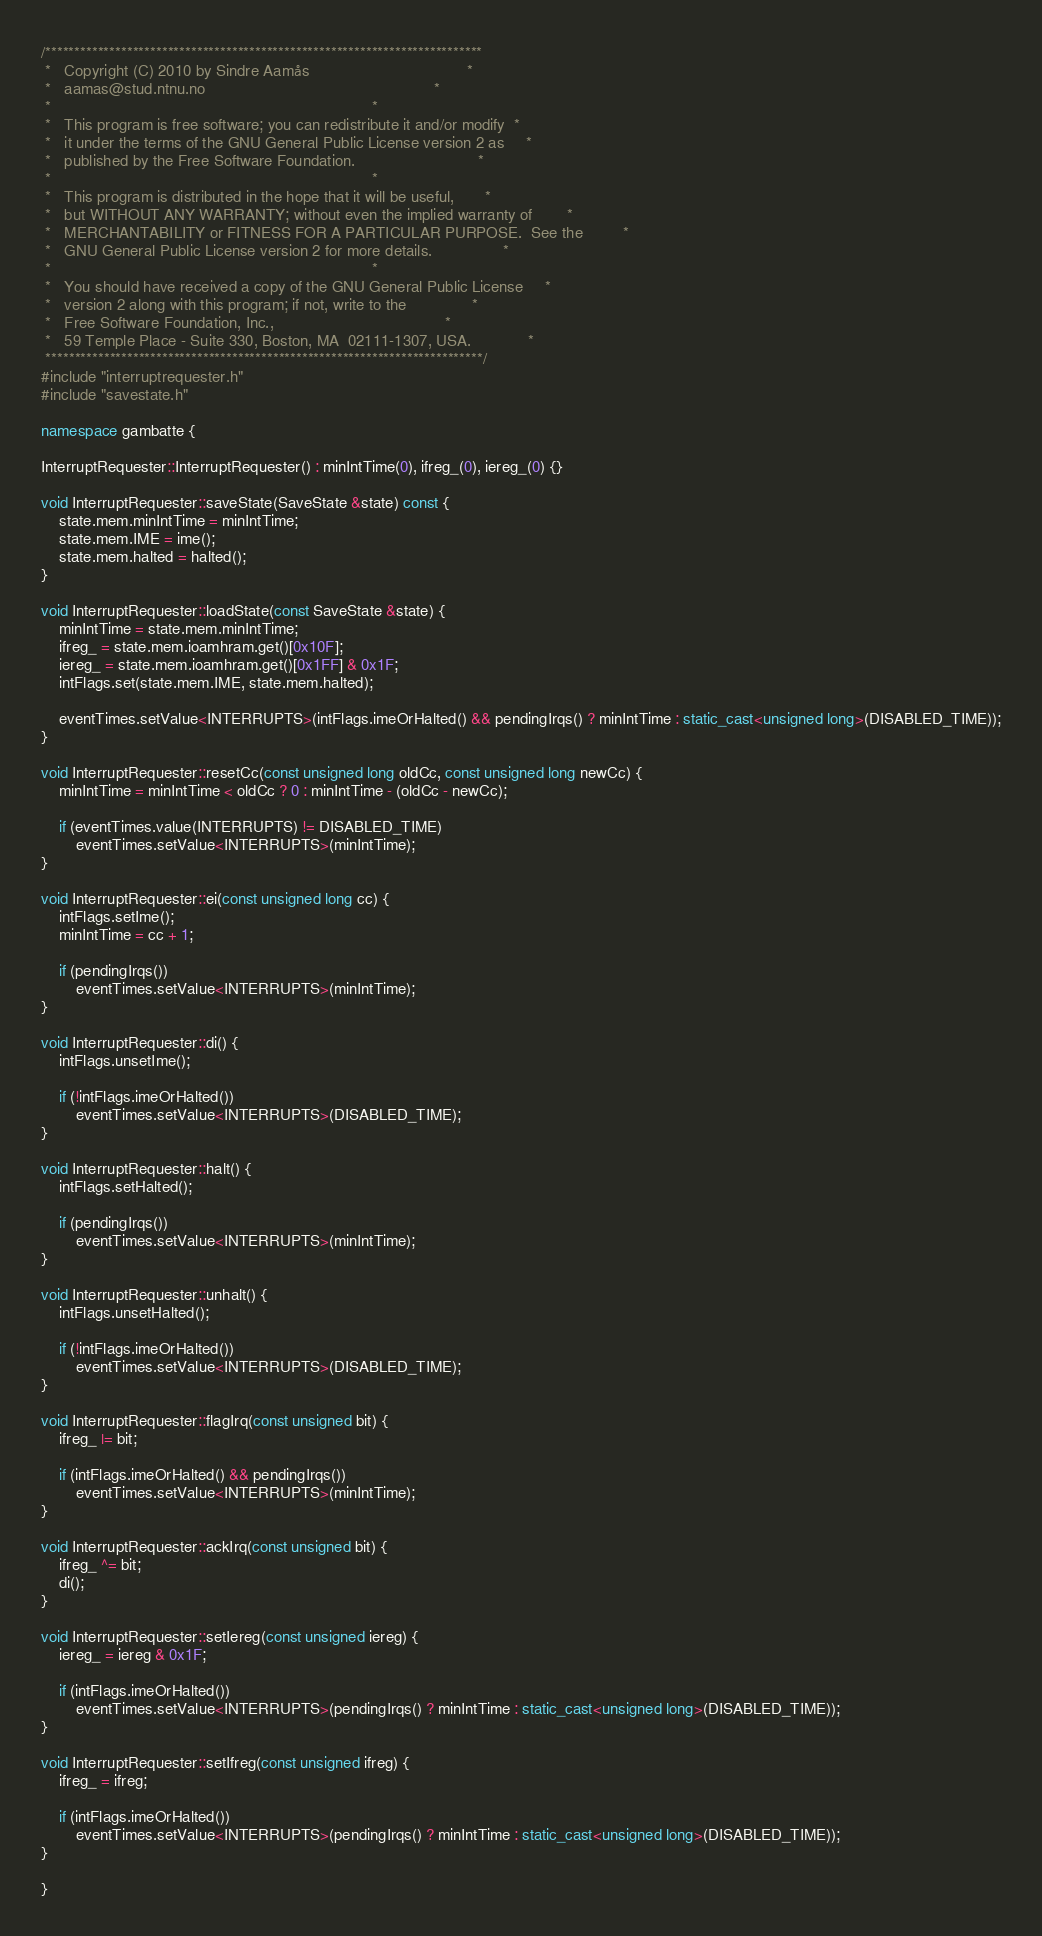Convert code to text. <code><loc_0><loc_0><loc_500><loc_500><_C++_>/***************************************************************************
 *   Copyright (C) 2010 by Sindre Aamås                                    *
 *   aamas@stud.ntnu.no                                                    *
 *                                                                         *
 *   This program is free software; you can redistribute it and/or modify  *
 *   it under the terms of the GNU General Public License version 2 as     *
 *   published by the Free Software Foundation.                            *
 *                                                                         *
 *   This program is distributed in the hope that it will be useful,       *
 *   but WITHOUT ANY WARRANTY; without even the implied warranty of        *
 *   MERCHANTABILITY or FITNESS FOR A PARTICULAR PURPOSE.  See the         *
 *   GNU General Public License version 2 for more details.                *
 *                                                                         *
 *   You should have received a copy of the GNU General Public License     *
 *   version 2 along with this program; if not, write to the               *
 *   Free Software Foundation, Inc.,                                       *
 *   59 Temple Place - Suite 330, Boston, MA  02111-1307, USA.             *
 ***************************************************************************/
#include "interruptrequester.h"
#include "savestate.h"

namespace gambatte {

InterruptRequester::InterruptRequester() : minIntTime(0), ifreg_(0), iereg_(0) {}

void InterruptRequester::saveState(SaveState &state) const {
	state.mem.minIntTime = minIntTime;
	state.mem.IME = ime();
	state.mem.halted = halted();
}

void InterruptRequester::loadState(const SaveState &state) {
	minIntTime = state.mem.minIntTime;
	ifreg_ = state.mem.ioamhram.get()[0x10F];
	iereg_ = state.mem.ioamhram.get()[0x1FF] & 0x1F;
	intFlags.set(state.mem.IME, state.mem.halted);
	
	eventTimes.setValue<INTERRUPTS>(intFlags.imeOrHalted() && pendingIrqs() ? minIntTime : static_cast<unsigned long>(DISABLED_TIME));
}

void InterruptRequester::resetCc(const unsigned long oldCc, const unsigned long newCc) {
	minIntTime = minIntTime < oldCc ? 0 : minIntTime - (oldCc - newCc);
	
	if (eventTimes.value(INTERRUPTS) != DISABLED_TIME)
		eventTimes.setValue<INTERRUPTS>(minIntTime);
}

void InterruptRequester::ei(const unsigned long cc) {
	intFlags.setIme();
	minIntTime = cc + 1;
	
	if (pendingIrqs())
		eventTimes.setValue<INTERRUPTS>(minIntTime);
}

void InterruptRequester::di() {
	intFlags.unsetIme();
	
	if (!intFlags.imeOrHalted())
		eventTimes.setValue<INTERRUPTS>(DISABLED_TIME);
}

void InterruptRequester::halt() {
	intFlags.setHalted();
	
	if (pendingIrqs())
		eventTimes.setValue<INTERRUPTS>(minIntTime);
}

void InterruptRequester::unhalt() {
	intFlags.unsetHalted();
	
	if (!intFlags.imeOrHalted())
		eventTimes.setValue<INTERRUPTS>(DISABLED_TIME);
}

void InterruptRequester::flagIrq(const unsigned bit) {
	ifreg_ |= bit;
	
	if (intFlags.imeOrHalted() && pendingIrqs())
		eventTimes.setValue<INTERRUPTS>(minIntTime);
}

void InterruptRequester::ackIrq(const unsigned bit) {
	ifreg_ ^= bit;
	di();
}

void InterruptRequester::setIereg(const unsigned iereg) {
	iereg_ = iereg & 0x1F;
	
	if (intFlags.imeOrHalted())
		eventTimes.setValue<INTERRUPTS>(pendingIrqs() ? minIntTime : static_cast<unsigned long>(DISABLED_TIME));
}

void InterruptRequester::setIfreg(const unsigned ifreg) {
	ifreg_ = ifreg;
	
	if (intFlags.imeOrHalted())
		eventTimes.setValue<INTERRUPTS>(pendingIrqs() ? minIntTime : static_cast<unsigned long>(DISABLED_TIME));
}

}
</code> 